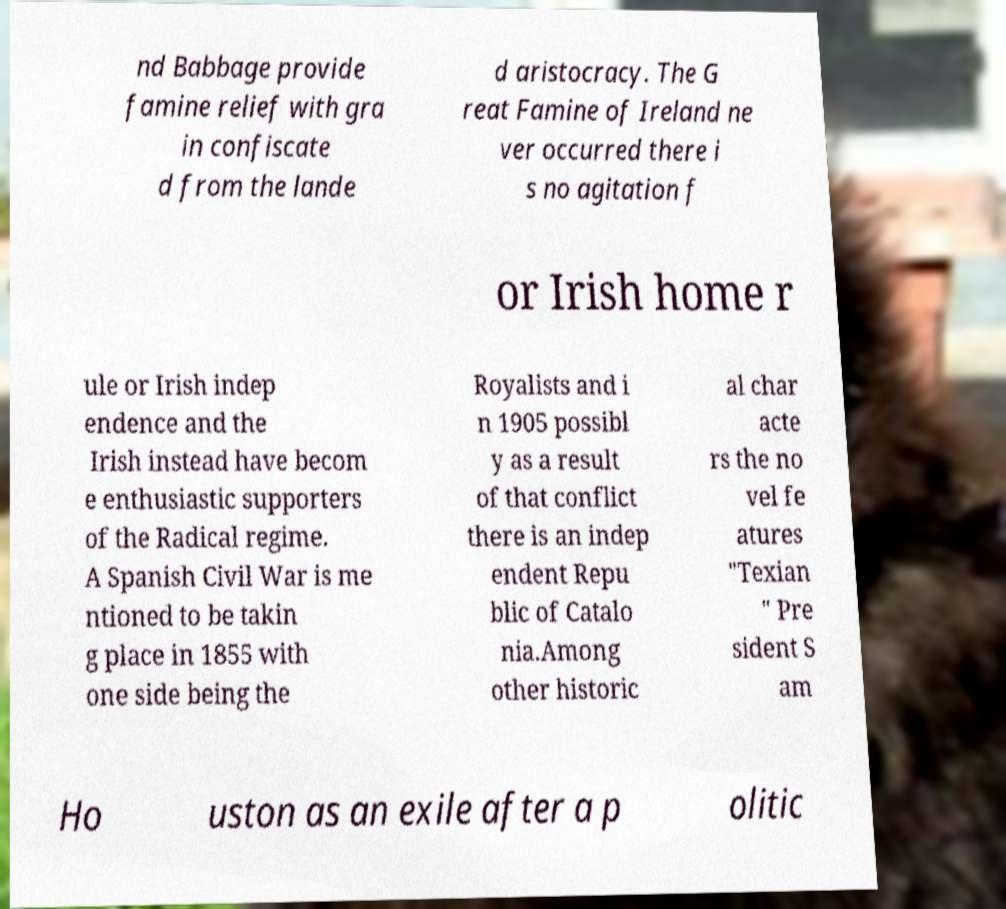There's text embedded in this image that I need extracted. Can you transcribe it verbatim? nd Babbage provide famine relief with gra in confiscate d from the lande d aristocracy. The G reat Famine of Ireland ne ver occurred there i s no agitation f or Irish home r ule or Irish indep endence and the Irish instead have becom e enthusiastic supporters of the Radical regime. A Spanish Civil War is me ntioned to be takin g place in 1855 with one side being the Royalists and i n 1905 possibl y as a result of that conflict there is an indep endent Repu blic of Catalo nia.Among other historic al char acte rs the no vel fe atures "Texian " Pre sident S am Ho uston as an exile after a p olitic 